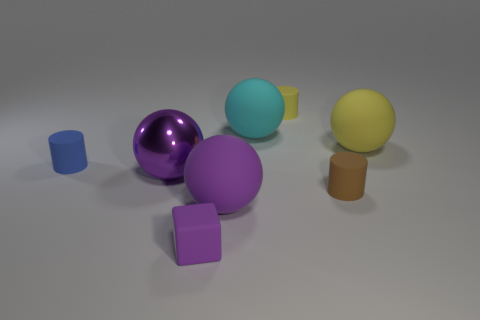What material is the tiny object that is on the right side of the small yellow thing?
Your answer should be compact. Rubber. Is there any other thing that is the same shape as the big metallic thing?
Provide a short and direct response. Yes. There is a tiny blue rubber object; does it have the same shape as the big thing behind the yellow rubber ball?
Keep it short and to the point. No. There is a metal thing that is the same shape as the big cyan matte object; what is its size?
Provide a short and direct response. Large. How many other objects are there of the same material as the large yellow object?
Offer a very short reply. 6. What is the big cyan sphere made of?
Provide a succinct answer. Rubber. There is a sphere that is in front of the brown object; is it the same color as the thing on the right side of the brown thing?
Make the answer very short. No. Is the number of tiny matte cubes that are behind the brown cylinder greater than the number of small green objects?
Offer a very short reply. No. What number of other objects are the same color as the large metal object?
Offer a terse response. 2. Do the sphere behind the yellow rubber ball and the tiny brown rubber object have the same size?
Ensure brevity in your answer.  No. 